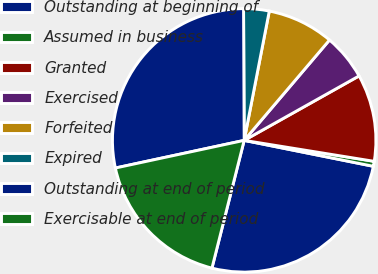<chart> <loc_0><loc_0><loc_500><loc_500><pie_chart><fcel>Outstanding at beginning of<fcel>Assumed in business<fcel>Granted<fcel>Exercised<fcel>Forfeited<fcel>Expired<fcel>Outstanding at end of period<fcel>Exercisable at end of period<nl><fcel>25.78%<fcel>0.61%<fcel>10.68%<fcel>5.65%<fcel>8.16%<fcel>3.13%<fcel>28.29%<fcel>17.7%<nl></chart> 